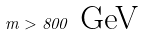Convert formula to latex. <formula><loc_0><loc_0><loc_500><loc_500>m > 8 0 0 \text { GeV}</formula> 